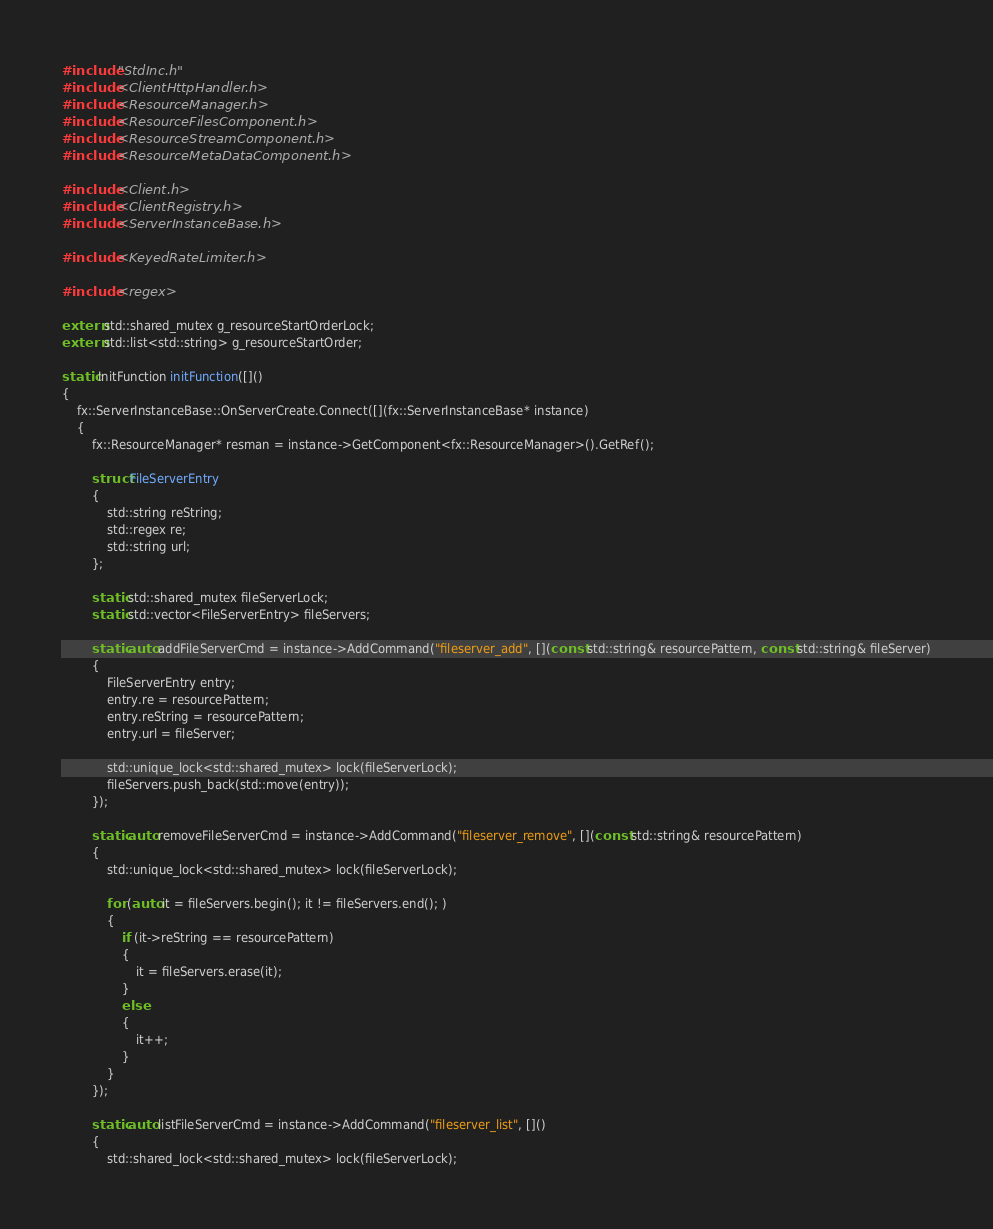<code> <loc_0><loc_0><loc_500><loc_500><_C++_>#include "StdInc.h"
#include <ClientHttpHandler.h>
#include <ResourceManager.h>
#include <ResourceFilesComponent.h>
#include <ResourceStreamComponent.h>
#include <ResourceMetaDataComponent.h>

#include <Client.h>
#include <ClientRegistry.h>
#include <ServerInstanceBase.h>

#include <KeyedRateLimiter.h>

#include <regex>

extern std::shared_mutex g_resourceStartOrderLock;
extern std::list<std::string> g_resourceStartOrder;

static InitFunction initFunction([]()
{
	fx::ServerInstanceBase::OnServerCreate.Connect([](fx::ServerInstanceBase* instance)
	{
		fx::ResourceManager* resman = instance->GetComponent<fx::ResourceManager>().GetRef();

		struct FileServerEntry
		{
			std::string reString;
			std::regex re;
			std::string url;
		};

		static std::shared_mutex fileServerLock;
		static std::vector<FileServerEntry> fileServers;

		static auto addFileServerCmd = instance->AddCommand("fileserver_add", [](const std::string& resourcePattern, const std::string& fileServer)
		{
			FileServerEntry entry;
			entry.re = resourcePattern;
			entry.reString = resourcePattern;
			entry.url = fileServer;

			std::unique_lock<std::shared_mutex> lock(fileServerLock);
			fileServers.push_back(std::move(entry));
		});

		static auto removeFileServerCmd = instance->AddCommand("fileserver_remove", [](const std::string& resourcePattern)
		{
			std::unique_lock<std::shared_mutex> lock(fileServerLock);

			for (auto it = fileServers.begin(); it != fileServers.end(); )
			{
				if (it->reString == resourcePattern)
				{
					it = fileServers.erase(it);
				}
				else
				{
					it++;
				}
			}
		});

		static auto listFileServerCmd = instance->AddCommand("fileserver_list", []()
		{
			std::shared_lock<std::shared_mutex> lock(fileServerLock);
</code> 